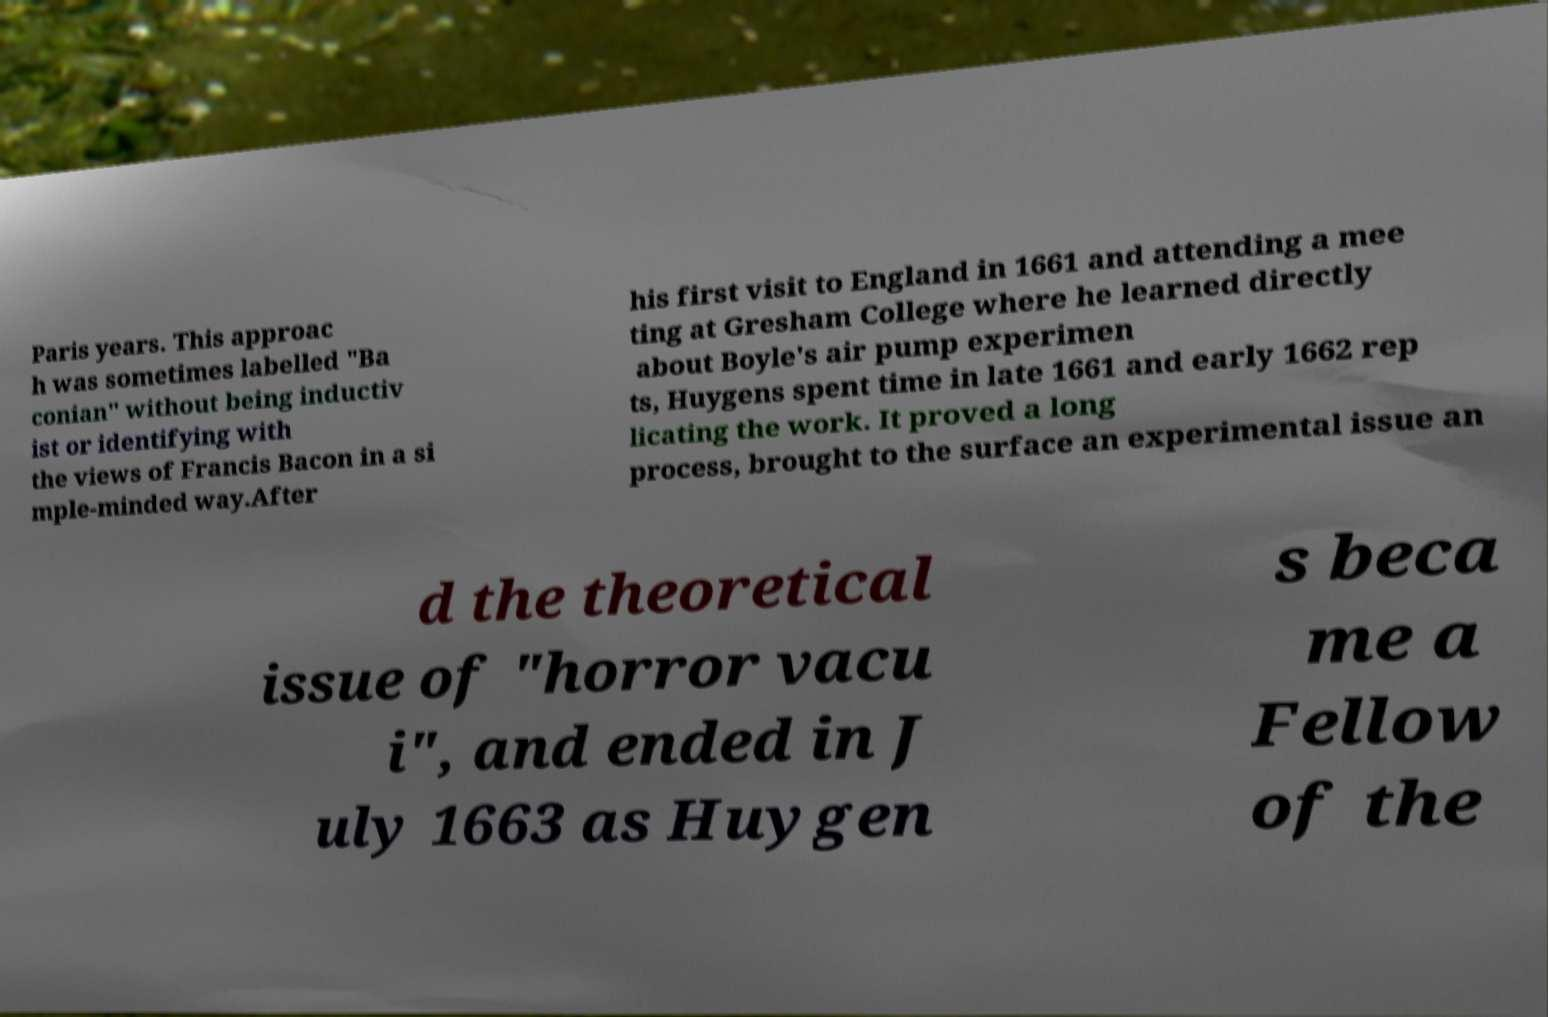Can you read and provide the text displayed in the image?This photo seems to have some interesting text. Can you extract and type it out for me? Paris years. This approac h was sometimes labelled "Ba conian" without being inductiv ist or identifying with the views of Francis Bacon in a si mple-minded way.After his first visit to England in 1661 and attending a mee ting at Gresham College where he learned directly about Boyle's air pump experimen ts, Huygens spent time in late 1661 and early 1662 rep licating the work. It proved a long process, brought to the surface an experimental issue an d the theoretical issue of "horror vacu i", and ended in J uly 1663 as Huygen s beca me a Fellow of the 